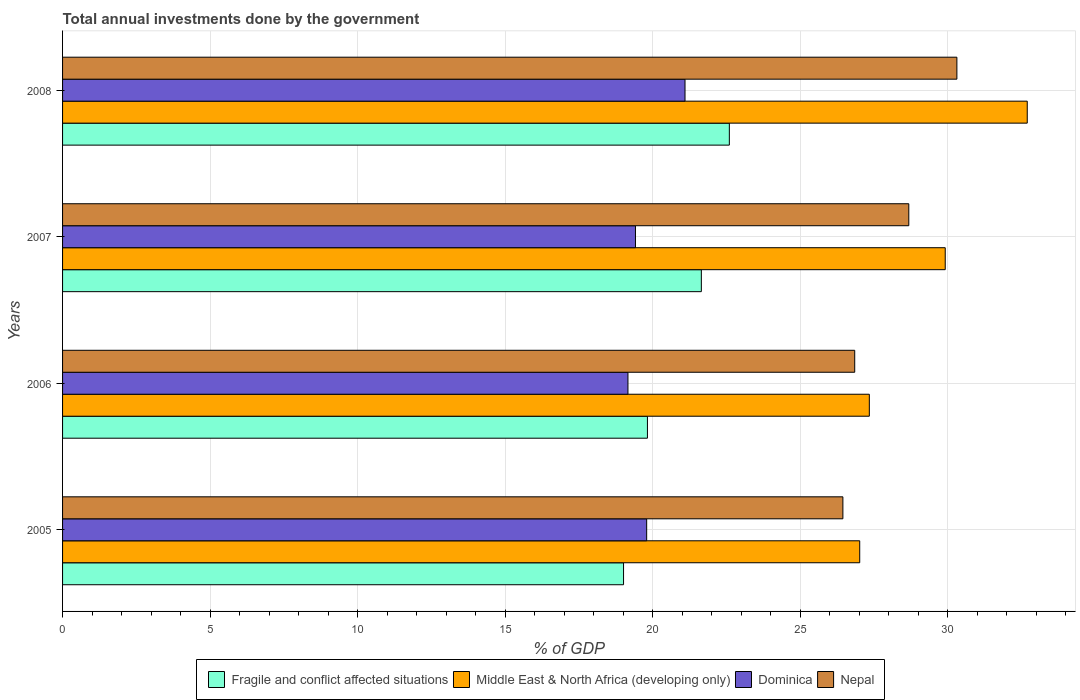How many different coloured bars are there?
Offer a very short reply. 4. How many groups of bars are there?
Give a very brief answer. 4. Are the number of bars per tick equal to the number of legend labels?
Provide a short and direct response. Yes. How many bars are there on the 2nd tick from the top?
Give a very brief answer. 4. How many bars are there on the 4th tick from the bottom?
Your response must be concise. 4. What is the label of the 2nd group of bars from the top?
Give a very brief answer. 2007. In how many cases, is the number of bars for a given year not equal to the number of legend labels?
Provide a succinct answer. 0. What is the total annual investments done by the government in Nepal in 2005?
Ensure brevity in your answer.  26.45. Across all years, what is the maximum total annual investments done by the government in Dominica?
Provide a short and direct response. 21.1. Across all years, what is the minimum total annual investments done by the government in Fragile and conflict affected situations?
Ensure brevity in your answer.  19.02. In which year was the total annual investments done by the government in Nepal minimum?
Provide a succinct answer. 2005. What is the total total annual investments done by the government in Middle East & North Africa (developing only) in the graph?
Offer a terse response. 116.99. What is the difference between the total annual investments done by the government in Nepal in 2007 and that in 2008?
Offer a very short reply. -1.63. What is the difference between the total annual investments done by the government in Middle East & North Africa (developing only) in 2008 and the total annual investments done by the government in Nepal in 2007?
Your response must be concise. 4.02. What is the average total annual investments done by the government in Nepal per year?
Your answer should be compact. 28.08. In the year 2005, what is the difference between the total annual investments done by the government in Fragile and conflict affected situations and total annual investments done by the government in Dominica?
Provide a succinct answer. -0.78. What is the ratio of the total annual investments done by the government in Dominica in 2005 to that in 2007?
Offer a very short reply. 1.02. Is the difference between the total annual investments done by the government in Fragile and conflict affected situations in 2005 and 2006 greater than the difference between the total annual investments done by the government in Dominica in 2005 and 2006?
Keep it short and to the point. No. What is the difference between the highest and the second highest total annual investments done by the government in Nepal?
Give a very brief answer. 1.63. What is the difference between the highest and the lowest total annual investments done by the government in Nepal?
Offer a terse response. 3.86. In how many years, is the total annual investments done by the government in Middle East & North Africa (developing only) greater than the average total annual investments done by the government in Middle East & North Africa (developing only) taken over all years?
Keep it short and to the point. 2. What does the 3rd bar from the top in 2006 represents?
Your answer should be very brief. Middle East & North Africa (developing only). What does the 2nd bar from the bottom in 2007 represents?
Offer a very short reply. Middle East & North Africa (developing only). How many bars are there?
Your answer should be compact. 16. Are all the bars in the graph horizontal?
Give a very brief answer. Yes. Does the graph contain grids?
Offer a very short reply. Yes. Where does the legend appear in the graph?
Give a very brief answer. Bottom center. How many legend labels are there?
Keep it short and to the point. 4. What is the title of the graph?
Your answer should be very brief. Total annual investments done by the government. What is the label or title of the X-axis?
Your answer should be compact. % of GDP. What is the label or title of the Y-axis?
Provide a succinct answer. Years. What is the % of GDP in Fragile and conflict affected situations in 2005?
Your answer should be very brief. 19.02. What is the % of GDP of Middle East & North Africa (developing only) in 2005?
Provide a succinct answer. 27.02. What is the % of GDP in Dominica in 2005?
Your answer should be compact. 19.8. What is the % of GDP of Nepal in 2005?
Give a very brief answer. 26.45. What is the % of GDP in Fragile and conflict affected situations in 2006?
Offer a very short reply. 19.83. What is the % of GDP in Middle East & North Africa (developing only) in 2006?
Make the answer very short. 27.35. What is the % of GDP of Dominica in 2006?
Your response must be concise. 19.17. What is the % of GDP in Nepal in 2006?
Ensure brevity in your answer.  26.85. What is the % of GDP in Fragile and conflict affected situations in 2007?
Your response must be concise. 21.65. What is the % of GDP in Middle East & North Africa (developing only) in 2007?
Offer a very short reply. 29.92. What is the % of GDP in Dominica in 2007?
Keep it short and to the point. 19.42. What is the % of GDP of Nepal in 2007?
Keep it short and to the point. 28.69. What is the % of GDP in Fragile and conflict affected situations in 2008?
Make the answer very short. 22.6. What is the % of GDP of Middle East & North Africa (developing only) in 2008?
Your answer should be compact. 32.7. What is the % of GDP of Dominica in 2008?
Your answer should be very brief. 21.1. What is the % of GDP of Nepal in 2008?
Give a very brief answer. 30.32. Across all years, what is the maximum % of GDP of Fragile and conflict affected situations?
Offer a very short reply. 22.6. Across all years, what is the maximum % of GDP in Middle East & North Africa (developing only)?
Provide a succinct answer. 32.7. Across all years, what is the maximum % of GDP of Dominica?
Keep it short and to the point. 21.1. Across all years, what is the maximum % of GDP in Nepal?
Provide a short and direct response. 30.32. Across all years, what is the minimum % of GDP of Fragile and conflict affected situations?
Offer a very short reply. 19.02. Across all years, what is the minimum % of GDP in Middle East & North Africa (developing only)?
Offer a very short reply. 27.02. Across all years, what is the minimum % of GDP in Dominica?
Your answer should be very brief. 19.17. Across all years, what is the minimum % of GDP in Nepal?
Ensure brevity in your answer.  26.45. What is the total % of GDP of Fragile and conflict affected situations in the graph?
Your answer should be very brief. 83.1. What is the total % of GDP of Middle East & North Africa (developing only) in the graph?
Provide a short and direct response. 116.99. What is the total % of GDP of Dominica in the graph?
Provide a succinct answer. 79.48. What is the total % of GDP of Nepal in the graph?
Keep it short and to the point. 112.3. What is the difference between the % of GDP of Fragile and conflict affected situations in 2005 and that in 2006?
Offer a terse response. -0.81. What is the difference between the % of GDP of Middle East & North Africa (developing only) in 2005 and that in 2006?
Your response must be concise. -0.33. What is the difference between the % of GDP of Dominica in 2005 and that in 2006?
Offer a very short reply. 0.63. What is the difference between the % of GDP of Nepal in 2005 and that in 2006?
Offer a terse response. -0.4. What is the difference between the % of GDP in Fragile and conflict affected situations in 2005 and that in 2007?
Make the answer very short. -2.64. What is the difference between the % of GDP of Middle East & North Africa (developing only) in 2005 and that in 2007?
Provide a short and direct response. -2.9. What is the difference between the % of GDP of Dominica in 2005 and that in 2007?
Offer a very short reply. 0.38. What is the difference between the % of GDP in Nepal in 2005 and that in 2007?
Give a very brief answer. -2.23. What is the difference between the % of GDP in Fragile and conflict affected situations in 2005 and that in 2008?
Provide a short and direct response. -3.59. What is the difference between the % of GDP of Middle East & North Africa (developing only) in 2005 and that in 2008?
Your answer should be compact. -5.68. What is the difference between the % of GDP in Dominica in 2005 and that in 2008?
Make the answer very short. -1.3. What is the difference between the % of GDP in Nepal in 2005 and that in 2008?
Give a very brief answer. -3.86. What is the difference between the % of GDP in Fragile and conflict affected situations in 2006 and that in 2007?
Make the answer very short. -1.83. What is the difference between the % of GDP in Middle East & North Africa (developing only) in 2006 and that in 2007?
Keep it short and to the point. -2.57. What is the difference between the % of GDP in Dominica in 2006 and that in 2007?
Your response must be concise. -0.25. What is the difference between the % of GDP of Nepal in 2006 and that in 2007?
Ensure brevity in your answer.  -1.83. What is the difference between the % of GDP of Fragile and conflict affected situations in 2006 and that in 2008?
Keep it short and to the point. -2.78. What is the difference between the % of GDP of Middle East & North Africa (developing only) in 2006 and that in 2008?
Your answer should be compact. -5.35. What is the difference between the % of GDP of Dominica in 2006 and that in 2008?
Provide a short and direct response. -1.93. What is the difference between the % of GDP of Nepal in 2006 and that in 2008?
Your response must be concise. -3.46. What is the difference between the % of GDP in Fragile and conflict affected situations in 2007 and that in 2008?
Keep it short and to the point. -0.95. What is the difference between the % of GDP of Middle East & North Africa (developing only) in 2007 and that in 2008?
Your response must be concise. -2.78. What is the difference between the % of GDP in Dominica in 2007 and that in 2008?
Provide a short and direct response. -1.68. What is the difference between the % of GDP of Nepal in 2007 and that in 2008?
Provide a short and direct response. -1.63. What is the difference between the % of GDP in Fragile and conflict affected situations in 2005 and the % of GDP in Middle East & North Africa (developing only) in 2006?
Provide a succinct answer. -8.33. What is the difference between the % of GDP in Fragile and conflict affected situations in 2005 and the % of GDP in Dominica in 2006?
Provide a short and direct response. -0.15. What is the difference between the % of GDP in Fragile and conflict affected situations in 2005 and the % of GDP in Nepal in 2006?
Ensure brevity in your answer.  -7.84. What is the difference between the % of GDP of Middle East & North Africa (developing only) in 2005 and the % of GDP of Dominica in 2006?
Your answer should be very brief. 7.86. What is the difference between the % of GDP in Middle East & North Africa (developing only) in 2005 and the % of GDP in Nepal in 2006?
Keep it short and to the point. 0.17. What is the difference between the % of GDP in Dominica in 2005 and the % of GDP in Nepal in 2006?
Give a very brief answer. -7.05. What is the difference between the % of GDP in Fragile and conflict affected situations in 2005 and the % of GDP in Middle East & North Africa (developing only) in 2007?
Make the answer very short. -10.9. What is the difference between the % of GDP of Fragile and conflict affected situations in 2005 and the % of GDP of Dominica in 2007?
Your answer should be compact. -0.4. What is the difference between the % of GDP in Fragile and conflict affected situations in 2005 and the % of GDP in Nepal in 2007?
Your answer should be very brief. -9.67. What is the difference between the % of GDP in Middle East & North Africa (developing only) in 2005 and the % of GDP in Dominica in 2007?
Offer a very short reply. 7.6. What is the difference between the % of GDP in Middle East & North Africa (developing only) in 2005 and the % of GDP in Nepal in 2007?
Offer a terse response. -1.66. What is the difference between the % of GDP of Dominica in 2005 and the % of GDP of Nepal in 2007?
Your response must be concise. -8.89. What is the difference between the % of GDP of Fragile and conflict affected situations in 2005 and the % of GDP of Middle East & North Africa (developing only) in 2008?
Provide a succinct answer. -13.68. What is the difference between the % of GDP in Fragile and conflict affected situations in 2005 and the % of GDP in Dominica in 2008?
Make the answer very short. -2.08. What is the difference between the % of GDP in Fragile and conflict affected situations in 2005 and the % of GDP in Nepal in 2008?
Provide a succinct answer. -11.3. What is the difference between the % of GDP in Middle East & North Africa (developing only) in 2005 and the % of GDP in Dominica in 2008?
Your answer should be compact. 5.92. What is the difference between the % of GDP in Middle East & North Africa (developing only) in 2005 and the % of GDP in Nepal in 2008?
Offer a terse response. -3.29. What is the difference between the % of GDP of Dominica in 2005 and the % of GDP of Nepal in 2008?
Your answer should be compact. -10.52. What is the difference between the % of GDP of Fragile and conflict affected situations in 2006 and the % of GDP of Middle East & North Africa (developing only) in 2007?
Provide a succinct answer. -10.09. What is the difference between the % of GDP in Fragile and conflict affected situations in 2006 and the % of GDP in Dominica in 2007?
Offer a terse response. 0.41. What is the difference between the % of GDP of Fragile and conflict affected situations in 2006 and the % of GDP of Nepal in 2007?
Offer a terse response. -8.86. What is the difference between the % of GDP of Middle East & North Africa (developing only) in 2006 and the % of GDP of Dominica in 2007?
Your answer should be compact. 7.93. What is the difference between the % of GDP in Middle East & North Africa (developing only) in 2006 and the % of GDP in Nepal in 2007?
Give a very brief answer. -1.34. What is the difference between the % of GDP in Dominica in 2006 and the % of GDP in Nepal in 2007?
Your answer should be compact. -9.52. What is the difference between the % of GDP in Fragile and conflict affected situations in 2006 and the % of GDP in Middle East & North Africa (developing only) in 2008?
Keep it short and to the point. -12.88. What is the difference between the % of GDP in Fragile and conflict affected situations in 2006 and the % of GDP in Dominica in 2008?
Your answer should be compact. -1.27. What is the difference between the % of GDP in Fragile and conflict affected situations in 2006 and the % of GDP in Nepal in 2008?
Give a very brief answer. -10.49. What is the difference between the % of GDP in Middle East & North Africa (developing only) in 2006 and the % of GDP in Dominica in 2008?
Your answer should be compact. 6.25. What is the difference between the % of GDP in Middle East & North Africa (developing only) in 2006 and the % of GDP in Nepal in 2008?
Offer a very short reply. -2.97. What is the difference between the % of GDP in Dominica in 2006 and the % of GDP in Nepal in 2008?
Offer a terse response. -11.15. What is the difference between the % of GDP in Fragile and conflict affected situations in 2007 and the % of GDP in Middle East & North Africa (developing only) in 2008?
Your answer should be very brief. -11.05. What is the difference between the % of GDP of Fragile and conflict affected situations in 2007 and the % of GDP of Dominica in 2008?
Make the answer very short. 0.55. What is the difference between the % of GDP in Fragile and conflict affected situations in 2007 and the % of GDP in Nepal in 2008?
Give a very brief answer. -8.66. What is the difference between the % of GDP of Middle East & North Africa (developing only) in 2007 and the % of GDP of Dominica in 2008?
Keep it short and to the point. 8.82. What is the difference between the % of GDP in Middle East & North Africa (developing only) in 2007 and the % of GDP in Nepal in 2008?
Offer a terse response. -0.4. What is the difference between the % of GDP in Dominica in 2007 and the % of GDP in Nepal in 2008?
Give a very brief answer. -10.9. What is the average % of GDP of Fragile and conflict affected situations per year?
Your answer should be very brief. 20.77. What is the average % of GDP of Middle East & North Africa (developing only) per year?
Provide a short and direct response. 29.25. What is the average % of GDP in Dominica per year?
Offer a very short reply. 19.87. What is the average % of GDP in Nepal per year?
Keep it short and to the point. 28.08. In the year 2005, what is the difference between the % of GDP of Fragile and conflict affected situations and % of GDP of Middle East & North Africa (developing only)?
Make the answer very short. -8.01. In the year 2005, what is the difference between the % of GDP of Fragile and conflict affected situations and % of GDP of Dominica?
Keep it short and to the point. -0.78. In the year 2005, what is the difference between the % of GDP in Fragile and conflict affected situations and % of GDP in Nepal?
Ensure brevity in your answer.  -7.44. In the year 2005, what is the difference between the % of GDP of Middle East & North Africa (developing only) and % of GDP of Dominica?
Ensure brevity in your answer.  7.22. In the year 2005, what is the difference between the % of GDP in Middle East & North Africa (developing only) and % of GDP in Nepal?
Your response must be concise. 0.57. In the year 2005, what is the difference between the % of GDP in Dominica and % of GDP in Nepal?
Your response must be concise. -6.65. In the year 2006, what is the difference between the % of GDP of Fragile and conflict affected situations and % of GDP of Middle East & North Africa (developing only)?
Your answer should be very brief. -7.52. In the year 2006, what is the difference between the % of GDP in Fragile and conflict affected situations and % of GDP in Dominica?
Offer a very short reply. 0.66. In the year 2006, what is the difference between the % of GDP of Fragile and conflict affected situations and % of GDP of Nepal?
Your response must be concise. -7.03. In the year 2006, what is the difference between the % of GDP in Middle East & North Africa (developing only) and % of GDP in Dominica?
Your answer should be compact. 8.18. In the year 2006, what is the difference between the % of GDP in Middle East & North Africa (developing only) and % of GDP in Nepal?
Make the answer very short. 0.5. In the year 2006, what is the difference between the % of GDP of Dominica and % of GDP of Nepal?
Keep it short and to the point. -7.69. In the year 2007, what is the difference between the % of GDP of Fragile and conflict affected situations and % of GDP of Middle East & North Africa (developing only)?
Ensure brevity in your answer.  -8.27. In the year 2007, what is the difference between the % of GDP of Fragile and conflict affected situations and % of GDP of Dominica?
Ensure brevity in your answer.  2.23. In the year 2007, what is the difference between the % of GDP in Fragile and conflict affected situations and % of GDP in Nepal?
Ensure brevity in your answer.  -7.03. In the year 2007, what is the difference between the % of GDP in Middle East & North Africa (developing only) and % of GDP in Dominica?
Offer a terse response. 10.5. In the year 2007, what is the difference between the % of GDP in Middle East & North Africa (developing only) and % of GDP in Nepal?
Offer a very short reply. 1.24. In the year 2007, what is the difference between the % of GDP of Dominica and % of GDP of Nepal?
Provide a short and direct response. -9.27. In the year 2008, what is the difference between the % of GDP of Fragile and conflict affected situations and % of GDP of Middle East & North Africa (developing only)?
Provide a succinct answer. -10.1. In the year 2008, what is the difference between the % of GDP in Fragile and conflict affected situations and % of GDP in Dominica?
Give a very brief answer. 1.5. In the year 2008, what is the difference between the % of GDP of Fragile and conflict affected situations and % of GDP of Nepal?
Ensure brevity in your answer.  -7.71. In the year 2008, what is the difference between the % of GDP of Middle East & North Africa (developing only) and % of GDP of Dominica?
Provide a succinct answer. 11.6. In the year 2008, what is the difference between the % of GDP in Middle East & North Africa (developing only) and % of GDP in Nepal?
Provide a succinct answer. 2.39. In the year 2008, what is the difference between the % of GDP of Dominica and % of GDP of Nepal?
Make the answer very short. -9.22. What is the ratio of the % of GDP of Fragile and conflict affected situations in 2005 to that in 2006?
Make the answer very short. 0.96. What is the ratio of the % of GDP in Dominica in 2005 to that in 2006?
Offer a terse response. 1.03. What is the ratio of the % of GDP of Nepal in 2005 to that in 2006?
Provide a succinct answer. 0.99. What is the ratio of the % of GDP of Fragile and conflict affected situations in 2005 to that in 2007?
Your response must be concise. 0.88. What is the ratio of the % of GDP of Middle East & North Africa (developing only) in 2005 to that in 2007?
Ensure brevity in your answer.  0.9. What is the ratio of the % of GDP of Dominica in 2005 to that in 2007?
Ensure brevity in your answer.  1.02. What is the ratio of the % of GDP of Nepal in 2005 to that in 2007?
Provide a succinct answer. 0.92. What is the ratio of the % of GDP of Fragile and conflict affected situations in 2005 to that in 2008?
Ensure brevity in your answer.  0.84. What is the ratio of the % of GDP of Middle East & North Africa (developing only) in 2005 to that in 2008?
Offer a very short reply. 0.83. What is the ratio of the % of GDP in Dominica in 2005 to that in 2008?
Provide a short and direct response. 0.94. What is the ratio of the % of GDP in Nepal in 2005 to that in 2008?
Give a very brief answer. 0.87. What is the ratio of the % of GDP in Fragile and conflict affected situations in 2006 to that in 2007?
Offer a very short reply. 0.92. What is the ratio of the % of GDP of Middle East & North Africa (developing only) in 2006 to that in 2007?
Your answer should be very brief. 0.91. What is the ratio of the % of GDP in Dominica in 2006 to that in 2007?
Keep it short and to the point. 0.99. What is the ratio of the % of GDP in Nepal in 2006 to that in 2007?
Your response must be concise. 0.94. What is the ratio of the % of GDP of Fragile and conflict affected situations in 2006 to that in 2008?
Make the answer very short. 0.88. What is the ratio of the % of GDP in Middle East & North Africa (developing only) in 2006 to that in 2008?
Your answer should be compact. 0.84. What is the ratio of the % of GDP of Dominica in 2006 to that in 2008?
Offer a terse response. 0.91. What is the ratio of the % of GDP of Nepal in 2006 to that in 2008?
Give a very brief answer. 0.89. What is the ratio of the % of GDP in Fragile and conflict affected situations in 2007 to that in 2008?
Offer a terse response. 0.96. What is the ratio of the % of GDP in Middle East & North Africa (developing only) in 2007 to that in 2008?
Your response must be concise. 0.92. What is the ratio of the % of GDP in Dominica in 2007 to that in 2008?
Ensure brevity in your answer.  0.92. What is the ratio of the % of GDP of Nepal in 2007 to that in 2008?
Offer a terse response. 0.95. What is the difference between the highest and the second highest % of GDP in Fragile and conflict affected situations?
Provide a short and direct response. 0.95. What is the difference between the highest and the second highest % of GDP in Middle East & North Africa (developing only)?
Provide a succinct answer. 2.78. What is the difference between the highest and the second highest % of GDP of Dominica?
Make the answer very short. 1.3. What is the difference between the highest and the second highest % of GDP in Nepal?
Your response must be concise. 1.63. What is the difference between the highest and the lowest % of GDP in Fragile and conflict affected situations?
Ensure brevity in your answer.  3.59. What is the difference between the highest and the lowest % of GDP in Middle East & North Africa (developing only)?
Make the answer very short. 5.68. What is the difference between the highest and the lowest % of GDP of Dominica?
Your answer should be compact. 1.93. What is the difference between the highest and the lowest % of GDP in Nepal?
Your answer should be very brief. 3.86. 